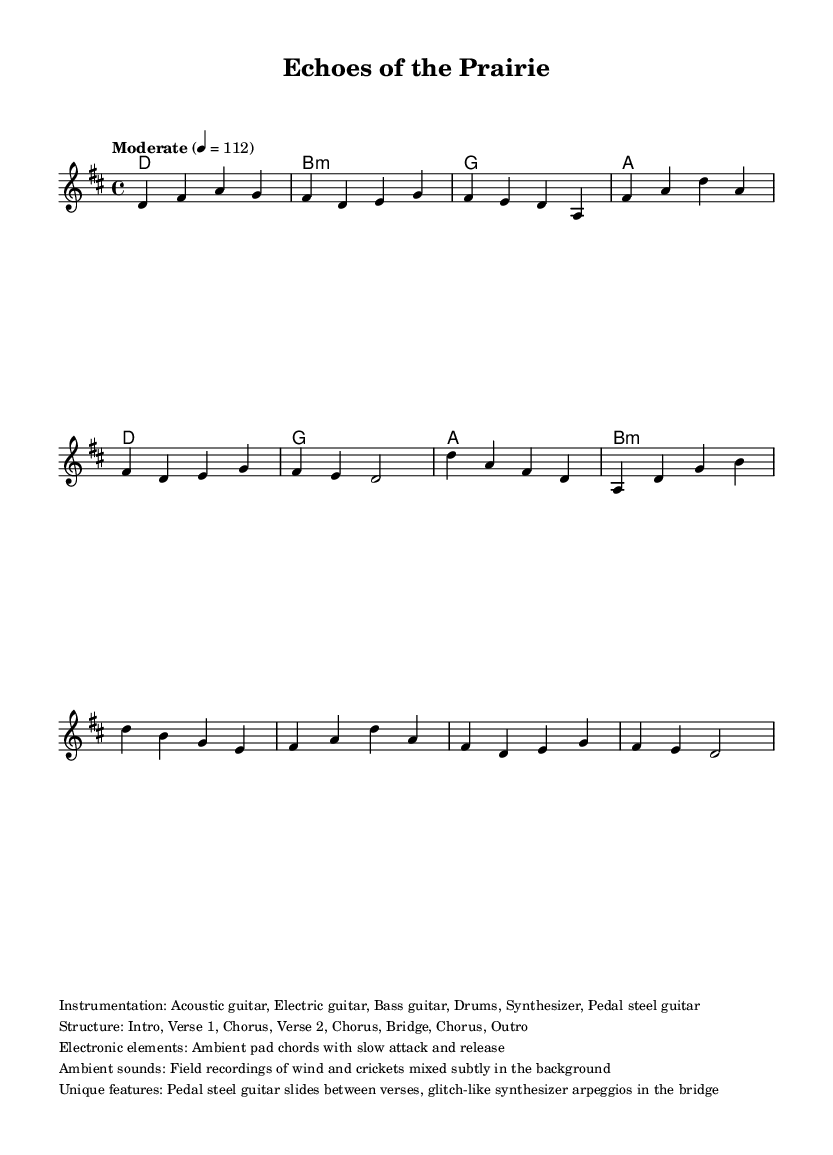What is the key signature of this music? The key signature is indicated at the beginning of the score. It shows two sharps, which correspond to F# and C#. This means the piece is in D major.
Answer: D major What is the time signature of this music? The time signature is shown at the beginning of the score, following the key signature. It indicates that the piece has 4 beats per measure, represented by 4/4.
Answer: 4/4 What is the tempo marking of this music? The tempo marking is indicated above the staff in the score. It states "Moderate" with a metronome marking of 112, meaning the music should be played at a moderate speed of 112 beats per minute.
Answer: 112 How many unique sections are there in the structure of this piece? The structure is detailed in the markup section where it lists the parts: Intro, Verse 1, Chorus, Verse 2, Chorus, Bridge, Chorus, and Outro. Counting these gives a total of 8 distinct sections.
Answer: 8 What are the main instruments used in this composition? The instrumentation is specified in the markup section. It lists Acoustic guitar, Electric guitar, Bass guitar, Drums, Synthesizer, and Pedal steel guitar. Therefore, there are six main instruments used in the composition.
Answer: Six What is a unique feature of the bridge section? The markup mentions "glitch-like synthesizer arpeggios in the bridge." This indicates that this particular section includes electronic elements that give it a unique sonic quality.
Answer: Glitch-like synthesizer arpeggios What types of ambient sounds are mixed into the background? The markup describes using field recordings of wind and crickets. These natural sounds create a subtle ambient texture that enhances the overall atmosphere of the piece.
Answer: Wind and crickets 